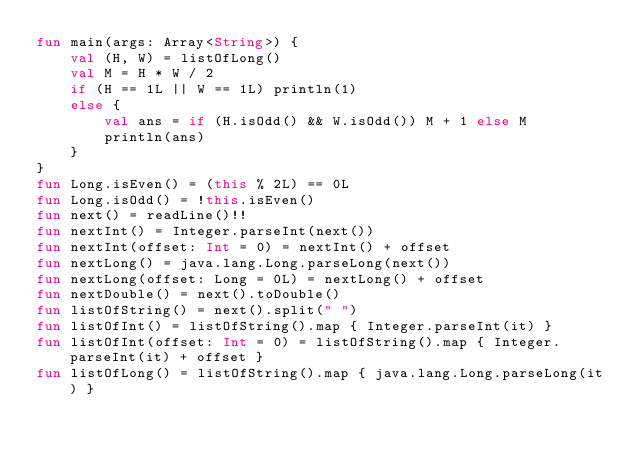Convert code to text. <code><loc_0><loc_0><loc_500><loc_500><_Kotlin_>fun main(args: Array<String>) {
    val (H, W) = listOfLong()
    val M = H * W / 2
    if (H == 1L || W == 1L) println(1)
    else {
        val ans = if (H.isOdd() && W.isOdd()) M + 1 else M
        println(ans)
    }
}
fun Long.isEven() = (this % 2L) == 0L
fun Long.isOdd() = !this.isEven()
fun next() = readLine()!!
fun nextInt() = Integer.parseInt(next())
fun nextInt(offset: Int = 0) = nextInt() + offset
fun nextLong() = java.lang.Long.parseLong(next())
fun nextLong(offset: Long = 0L) = nextLong() + offset
fun nextDouble() = next().toDouble()
fun listOfString() = next().split(" ")
fun listOfInt() = listOfString().map { Integer.parseInt(it) }
fun listOfInt(offset: Int = 0) = listOfString().map { Integer.parseInt(it) + offset }
fun listOfLong() = listOfString().map { java.lang.Long.parseLong(it) }
</code> 